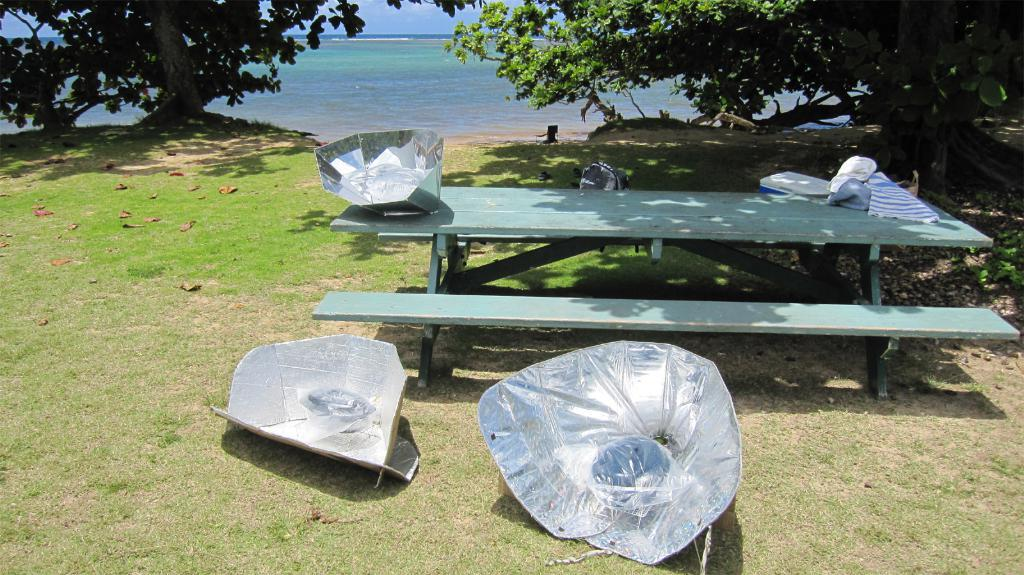What is the main object in the image? There is a table in the image. What is placed on the table? There are steel papers on the table. Are there any steel papers on the ground? Yes, there are steel papers on the ground. What can be seen in the background of the image? There is a lake and trees visible at the top of the image. What type of scarf is being used as a kite in the image? There is no scarf or kite present in the image. What type of vacation is being depicted in the image? The image does not depict a vacation; it shows a table with steel papers on it and a background with a lake and trees. 